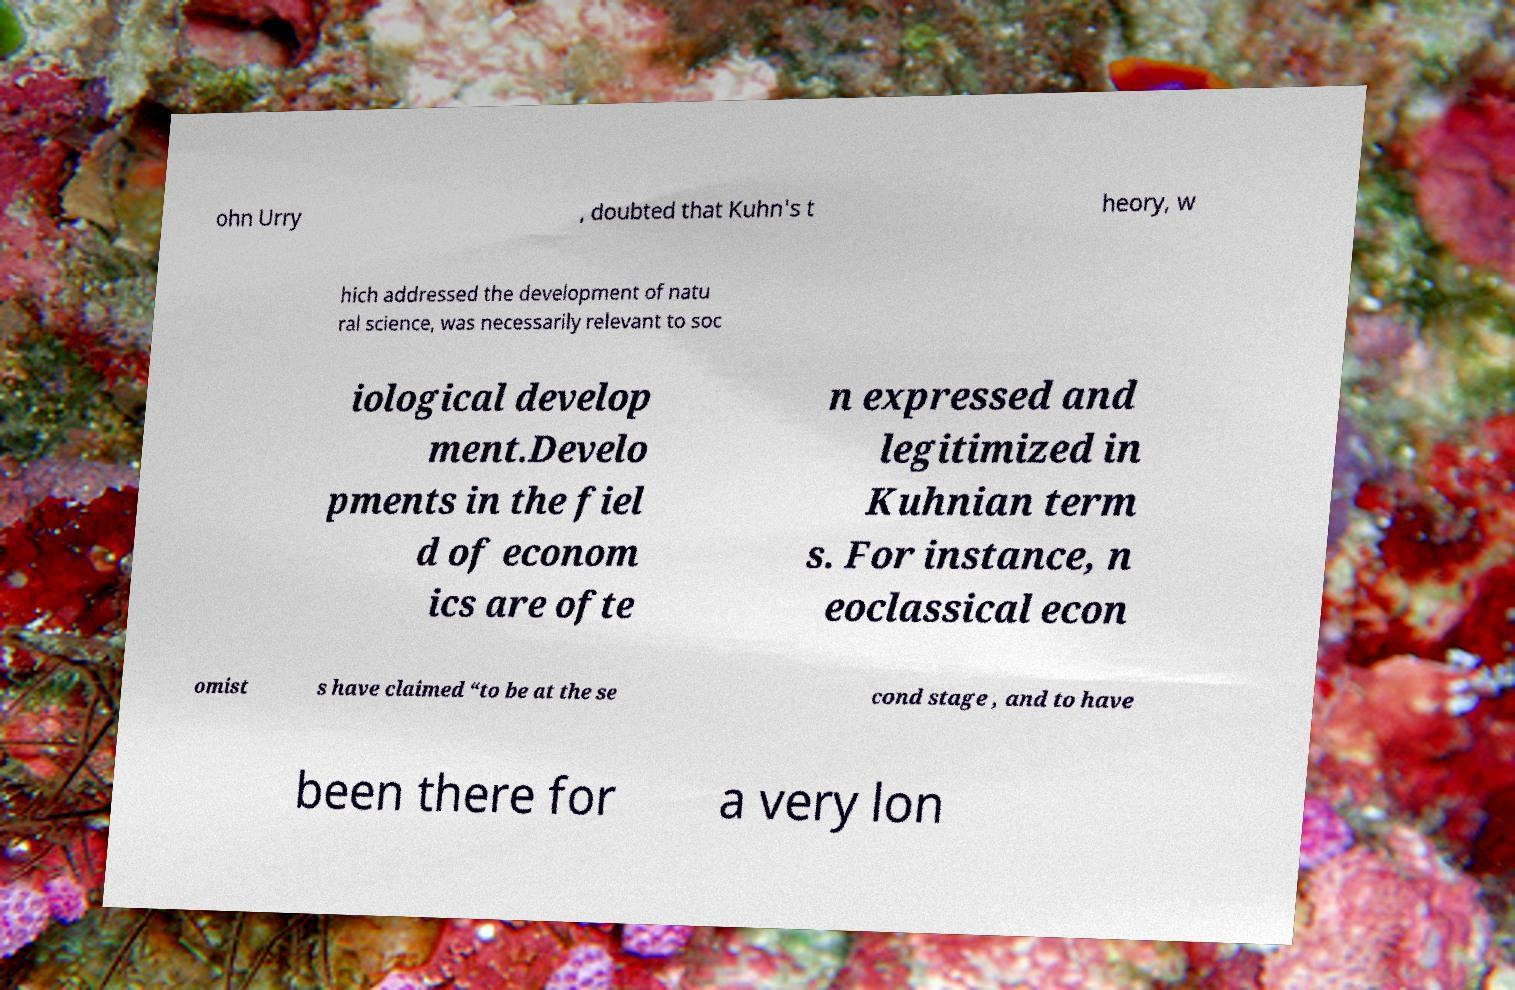Can you accurately transcribe the text from the provided image for me? ohn Urry , doubted that Kuhn's t heory, w hich addressed the development of natu ral science, was necessarily relevant to soc iological develop ment.Develo pments in the fiel d of econom ics are ofte n expressed and legitimized in Kuhnian term s. For instance, n eoclassical econ omist s have claimed “to be at the se cond stage , and to have been there for a very lon 